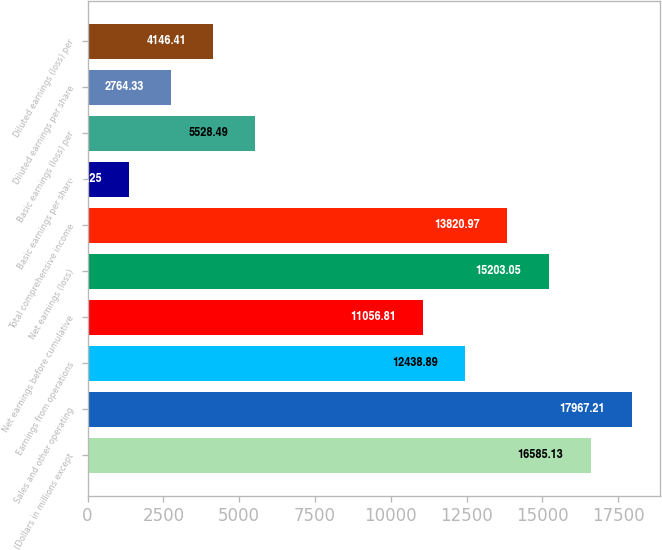<chart> <loc_0><loc_0><loc_500><loc_500><bar_chart><fcel>(Dollars in millions except<fcel>Sales and other operating<fcel>Earnings from operations<fcel>Net earnings before cumulative<fcel>Net earnings (loss)<fcel>Total comprehensive income<fcel>Basic earnings per share<fcel>Basic earnings (loss) per<fcel>Diluted earnings per share<fcel>Diluted earnings (loss) per<nl><fcel>16585.1<fcel>17967.2<fcel>12438.9<fcel>11056.8<fcel>15203<fcel>13821<fcel>1382.25<fcel>5528.49<fcel>2764.33<fcel>4146.41<nl></chart> 